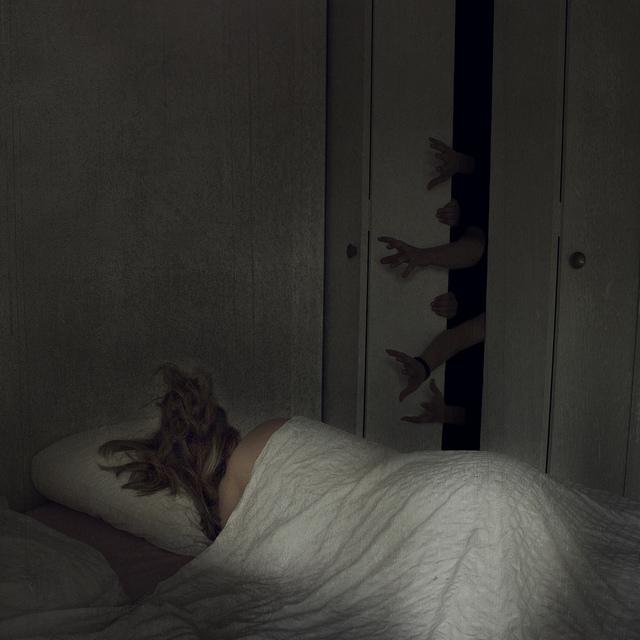Do you think this image is creepy?
Be succinct. Yes. What is one here head?
Give a very brief answer. Hair. What color is the dog?
Keep it brief. No dog. What kind of movie would this image be in?
Keep it brief. Horror. Is the girl on motion?
Quick response, please. No. What is the puppy leaning on?
Concise answer only. Person. Is anyone sleeping?
Write a very short answer. Yes. 